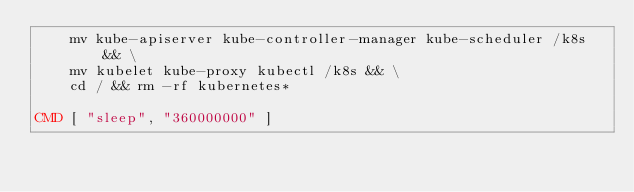<code> <loc_0><loc_0><loc_500><loc_500><_Dockerfile_>    mv kube-apiserver kube-controller-manager kube-scheduler /k8s && \
    mv kubelet kube-proxy kubectl /k8s && \
    cd / && rm -rf kubernetes*

CMD [ "sleep", "360000000" ]
</code> 